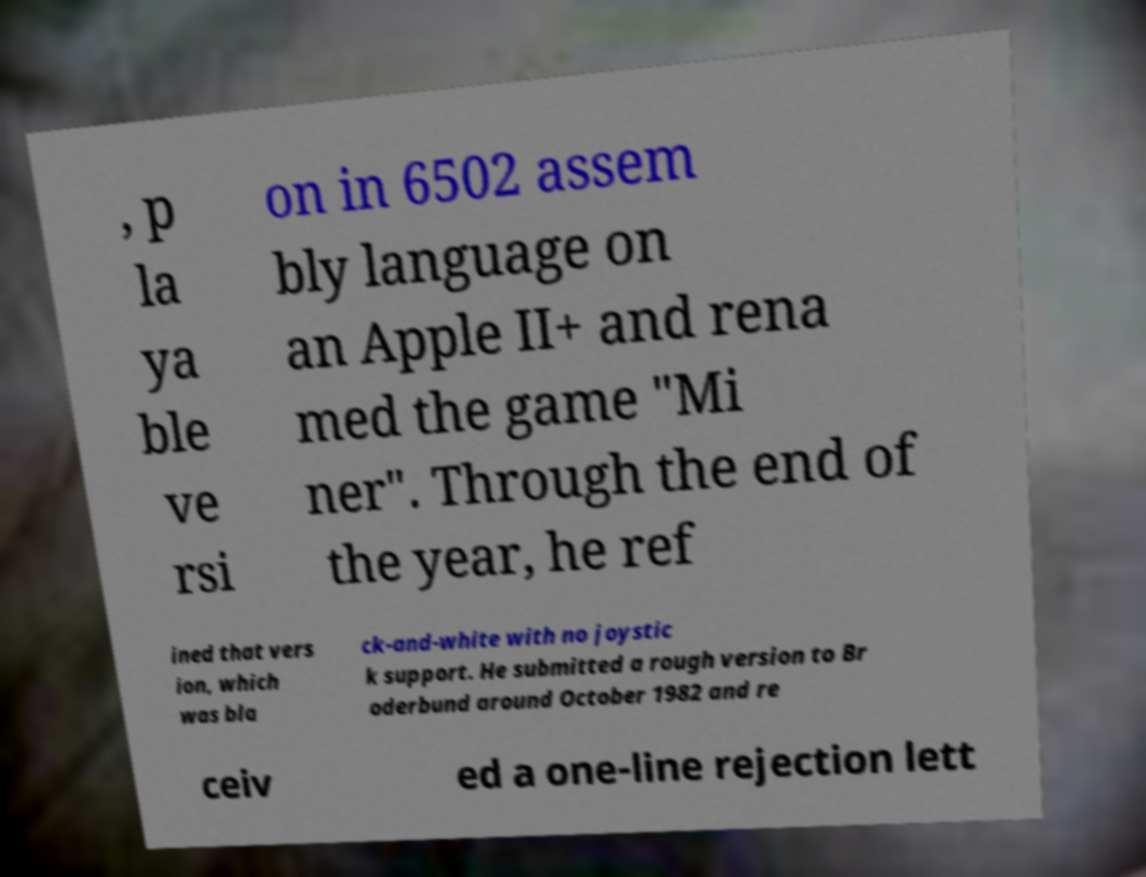Could you extract and type out the text from this image? , p la ya ble ve rsi on in 6502 assem bly language on an Apple II+ and rena med the game "Mi ner". Through the end of the year, he ref ined that vers ion, which was bla ck-and-white with no joystic k support. He submitted a rough version to Br oderbund around October 1982 and re ceiv ed a one-line rejection lett 